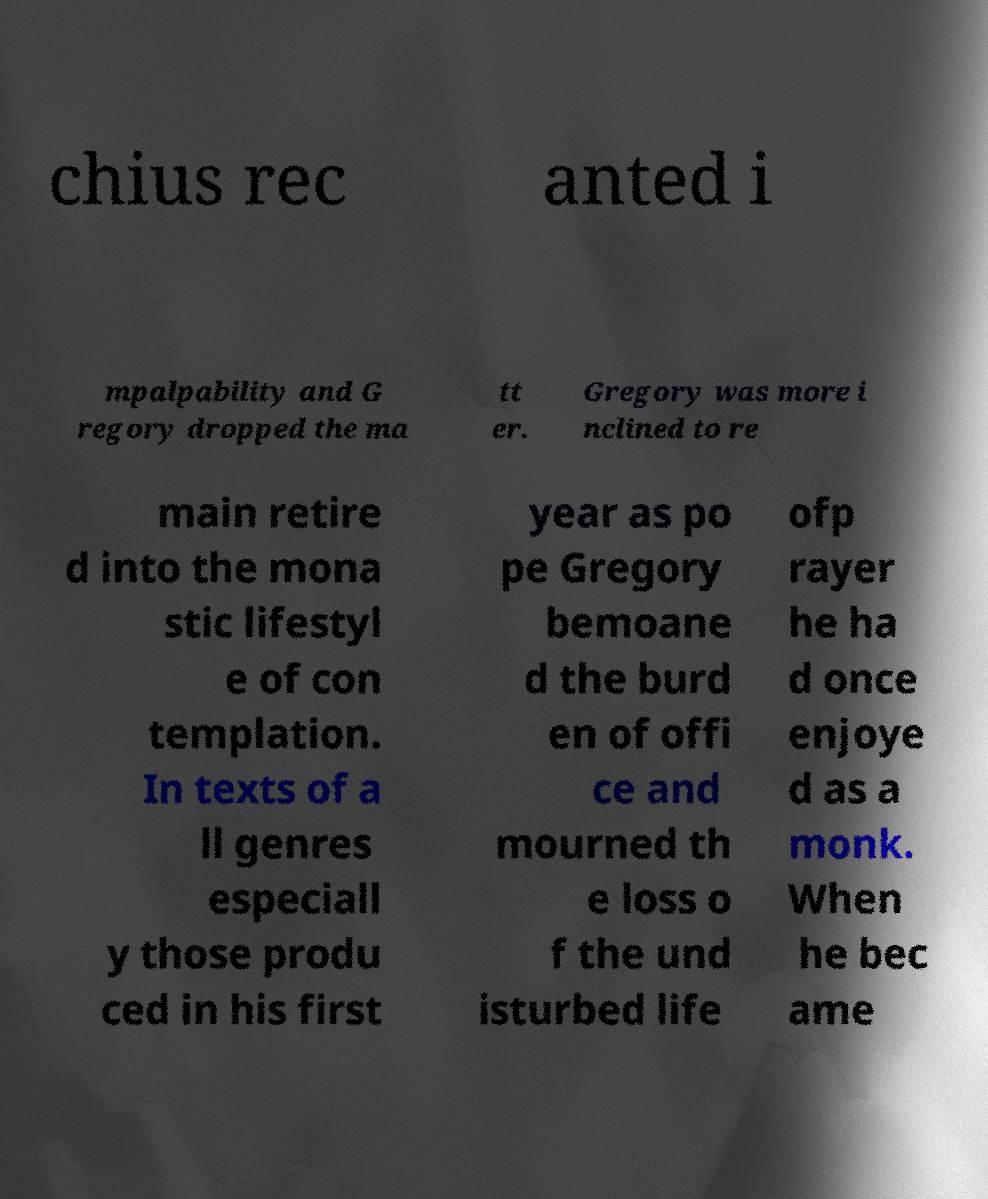Can you read and provide the text displayed in the image?This photo seems to have some interesting text. Can you extract and type it out for me? chius rec anted i mpalpability and G regory dropped the ma tt er. Gregory was more i nclined to re main retire d into the mona stic lifestyl e of con templation. In texts of a ll genres especiall y those produ ced in his first year as po pe Gregory bemoane d the burd en of offi ce and mourned th e loss o f the und isturbed life ofp rayer he ha d once enjoye d as a monk. When he bec ame 